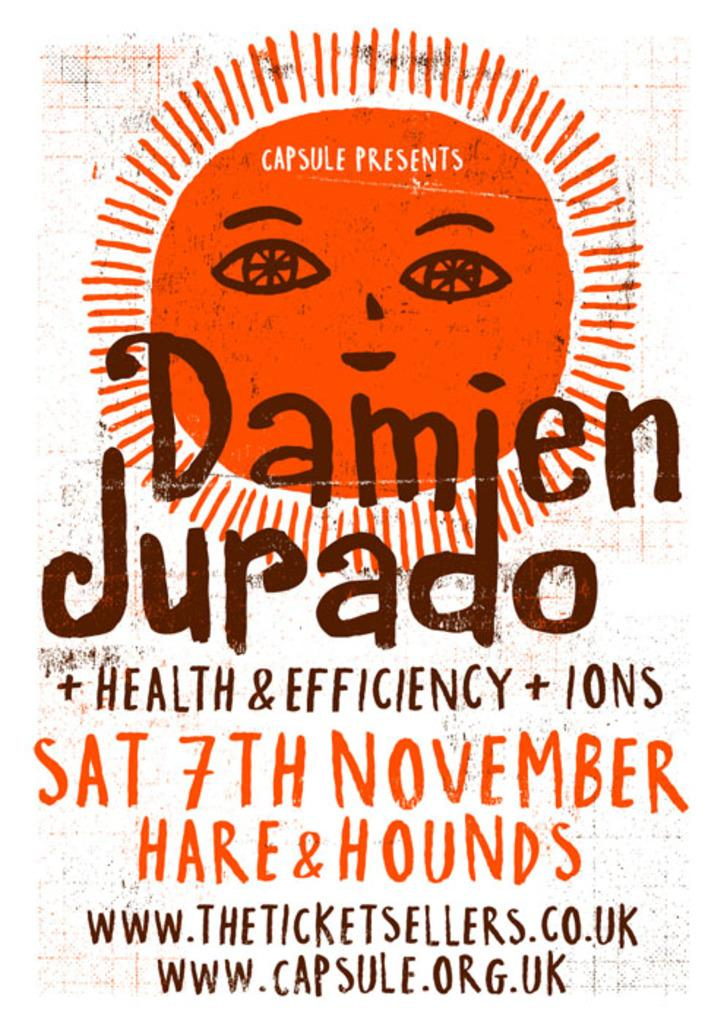<image>
Render a clear and concise summary of the photo. a red white and brown sign advertising for an event on saturday nobvember 7th 